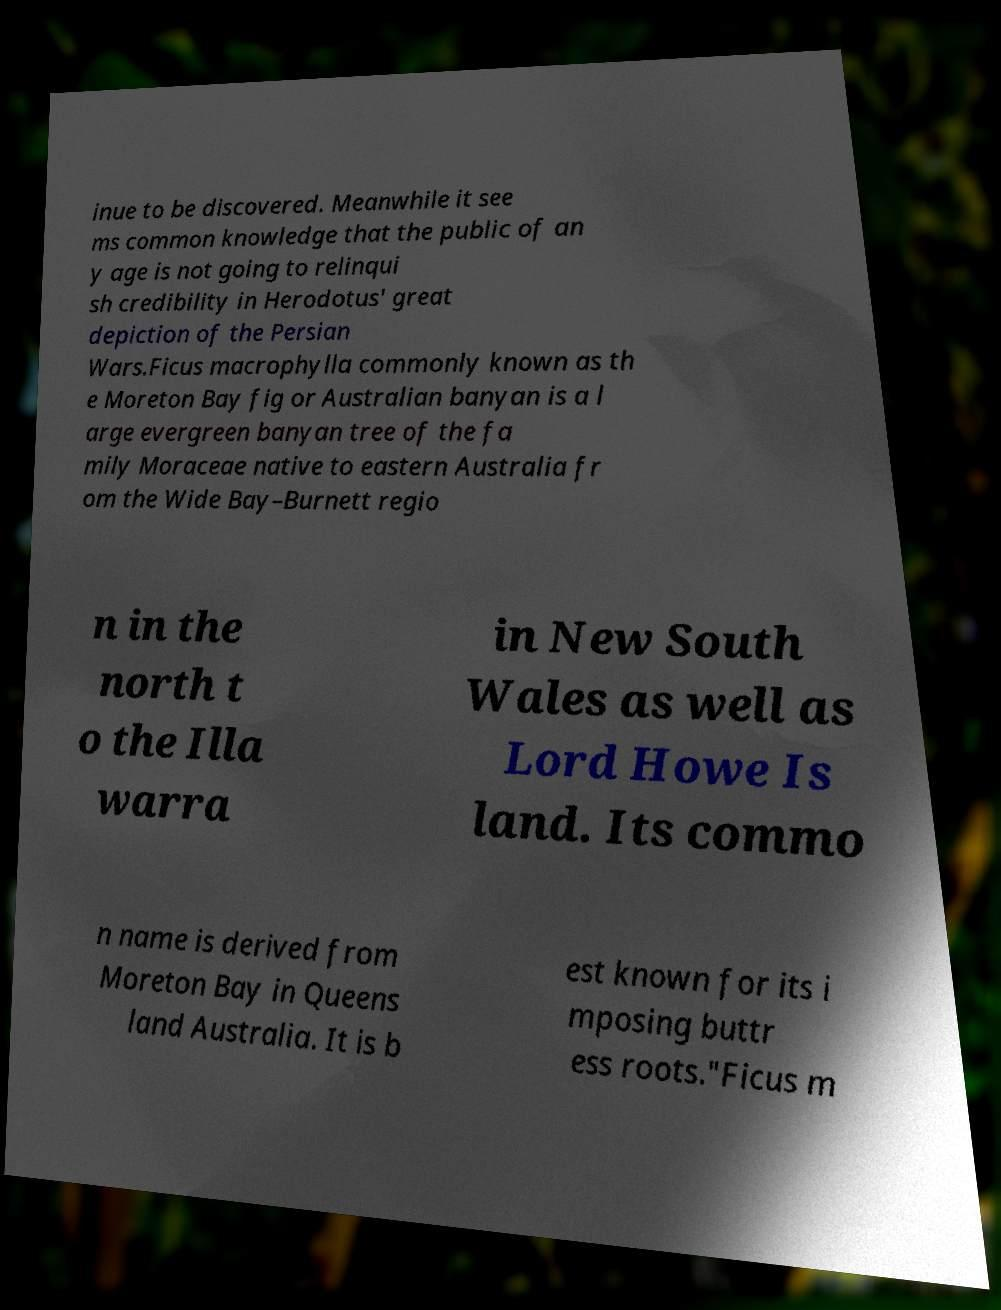Please identify and transcribe the text found in this image. inue to be discovered. Meanwhile it see ms common knowledge that the public of an y age is not going to relinqui sh credibility in Herodotus' great depiction of the Persian Wars.Ficus macrophylla commonly known as th e Moreton Bay fig or Australian banyan is a l arge evergreen banyan tree of the fa mily Moraceae native to eastern Australia fr om the Wide Bay–Burnett regio n in the north t o the Illa warra in New South Wales as well as Lord Howe Is land. Its commo n name is derived from Moreton Bay in Queens land Australia. It is b est known for its i mposing buttr ess roots."Ficus m 